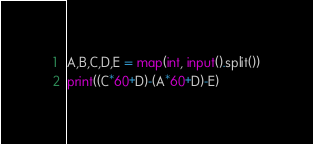<code> <loc_0><loc_0><loc_500><loc_500><_Python_>A,B,C,D,E = map(int, input().split())
print((C*60+D)-(A*60+D)-E)</code> 